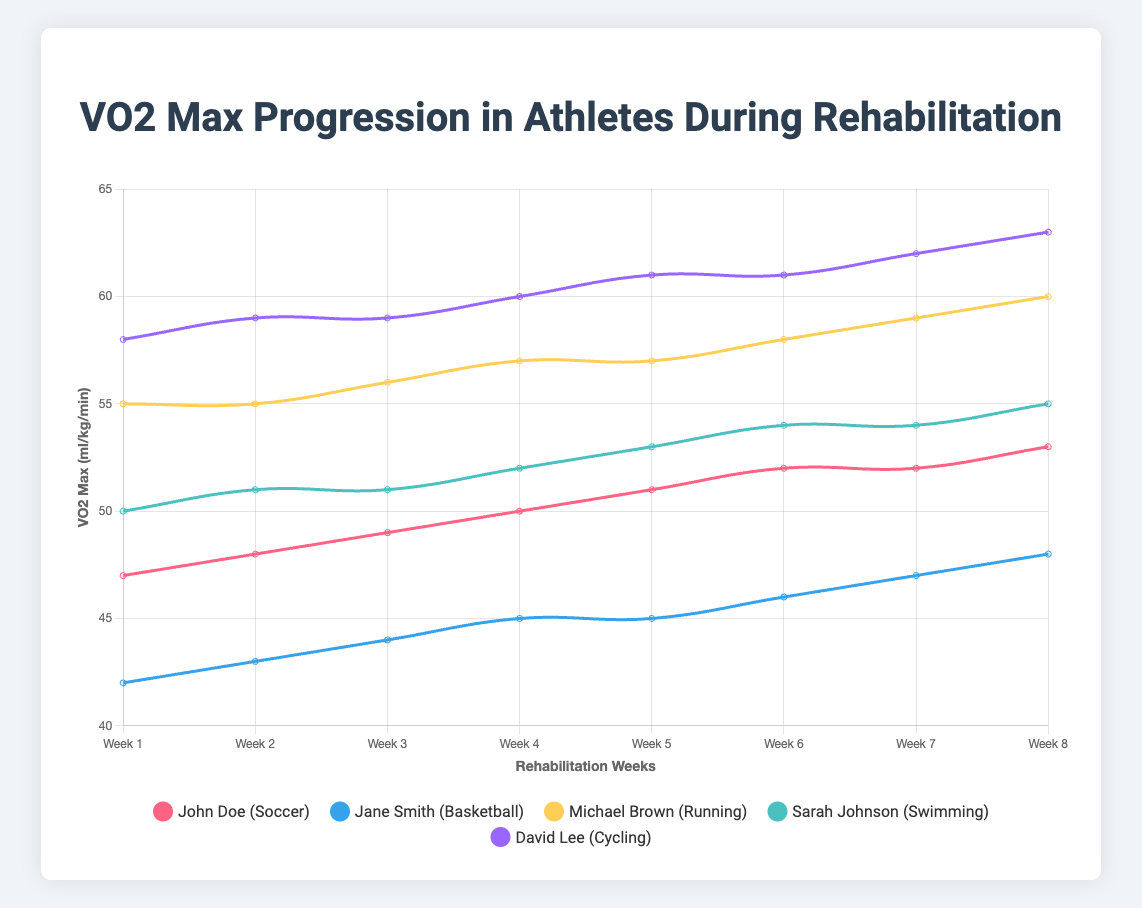What's the initial VO2 max of John Doe? John Doe's initial VO2 max can be seen at the start of the line chart traced for him. It is the first value in the dataset.
Answer: 47 ml/kg/min Which athlete had the highest VO2 max at the end of the 8-week rehabilitation? To determine this, look at the final data points for each line on the chart. Identify the highest value among these.
Answer: David Lee Who showed the most consistent improvement in VO2 max every week? Consistency can be observed by a line with steady increments each week without drops or stagnations. Comparing all lines, Michael Brown's VO2 max consistently increased each week.
Answer: Michael Brown Did Sarah Johnson have any weeks where her VO2 max did not improve? Review Sarah Johnson's line on the chart. If there are any flat sections (no increase), these would indicate weeks with no improvement. Indeed, during weeks 3 and 7, there was no improvement.
Answer: Yes By how much did Jane Smith’s VO2 max improve from Week 1 to Week 8? Find the difference between the Week 8 value and the Week 1 value for Jane Smith. Week 8 VO2 max is 48 and Week 1 VO2 max is 42. The difference is 48 - 42.
Answer: 6 ml/kg/min Which athlete experienced the largest drop in VO2 max in any given week? A drop is represented by a downward trend between two consecutive weeks. John Doe’s VO2 max remained constant for a week, but no declines are observed in any athlete.
Answer: None What's the average VO2 max of David Lee over the 8 weeks? Sum up David Lee's VO2 max values for all weeks: 58 + 59 + 59 + 60 + 61 + 61 + 62 + 63 = 483. Divide by the number of weeks (8) to get the average.
Answer: 60.375 ml/kg/min Which two athletes had the same VO2 max in the third week? Compare the third-week values for each athlete. Both Michael Brown and David Lee had a VO2 max of 59 in the third week.
Answer: Michael Brown and David Lee 